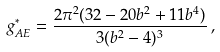Convert formula to latex. <formula><loc_0><loc_0><loc_500><loc_500>g ^ { * } _ { A E } = \frac { 2 \pi ^ { 2 } ( 3 2 - 2 0 b ^ { 2 } + 1 1 b ^ { 4 } ) } { 3 ( b ^ { 2 } - 4 ) ^ { 3 } } \, ,</formula> 